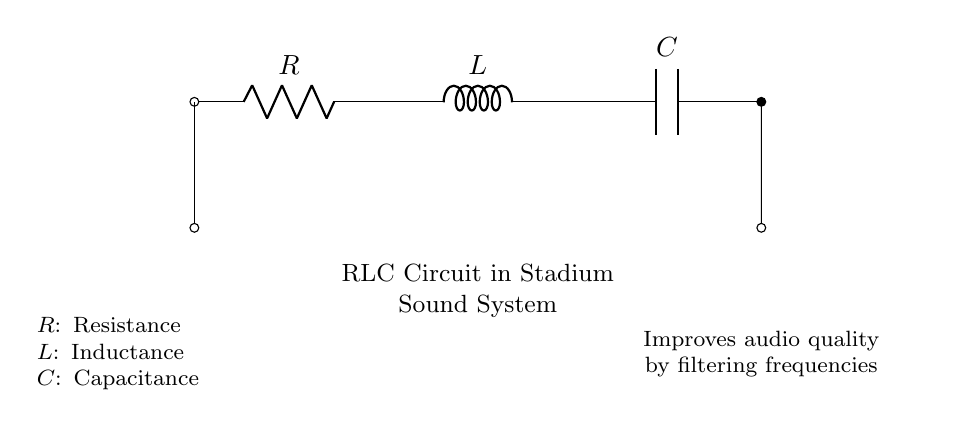What are the components in the circuit? The circuit consists of a resistor, an inductor, and a capacitor, which are standard elements in an RLC circuit.
Answer: resistor, inductor, capacitor What is the purpose of this RLC circuit? The purpose of the RLC circuit in the stadium sound system is to improve audio quality by filtering frequencies.
Answer: improve audio quality Which component is represented by the letter "L"? The letter "L" stands for inductance, which is the property of the inductor in the circuit that opposes changes in current.
Answer: inductance How does this circuit affect audio frequencies? This RLC circuit is designed to filter certain frequencies, allowing for better audio quality by either enhancing or attenuating specific audio signals.
Answer: filtering frequencies What is the relationship between resistance, inductance, and capacitance in this circuit? The relationship is that these three components together determine the circuit's overall impedance, which influences how the circuit reacts to different frequencies, providing critical tuning for audio systems.
Answer: overall impedance What role does the capacitor play in this circuit? The capacitor stores and releases electrical energy, smoothing out variations in the audio signal and aiding in frequency filtering to enhance sound quality.
Answer: smooths audio signal How can the values of R, L, and C affect audio quality? Changing the values of resistance, inductance, and capacitance will alter the circuit's cutoff frequency, which ultimately affects which audio frequencies are amplified or attenuated.
Answer: alters cutoff frequency 